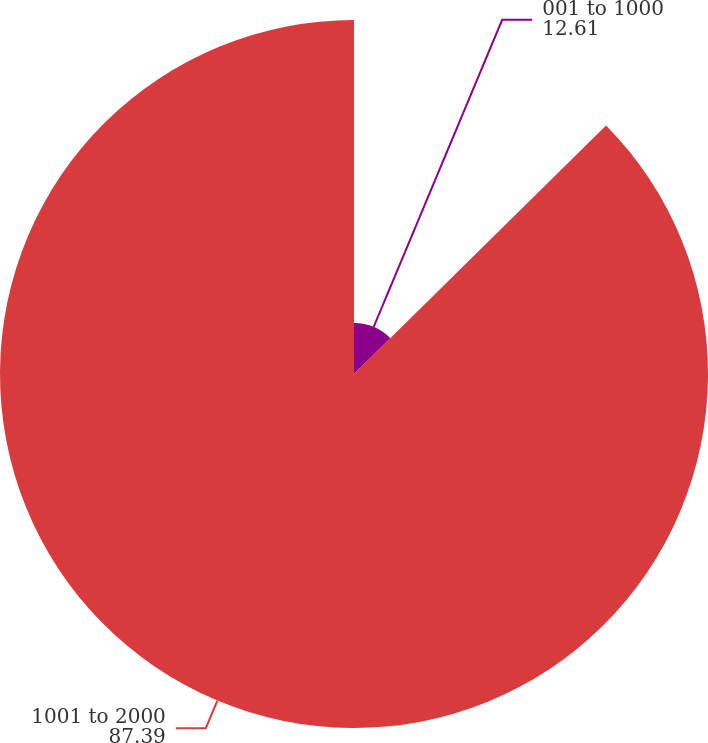<chart> <loc_0><loc_0><loc_500><loc_500><pie_chart><fcel>001 to 1000<fcel>1001 to 2000<nl><fcel>12.61%<fcel>87.39%<nl></chart> 